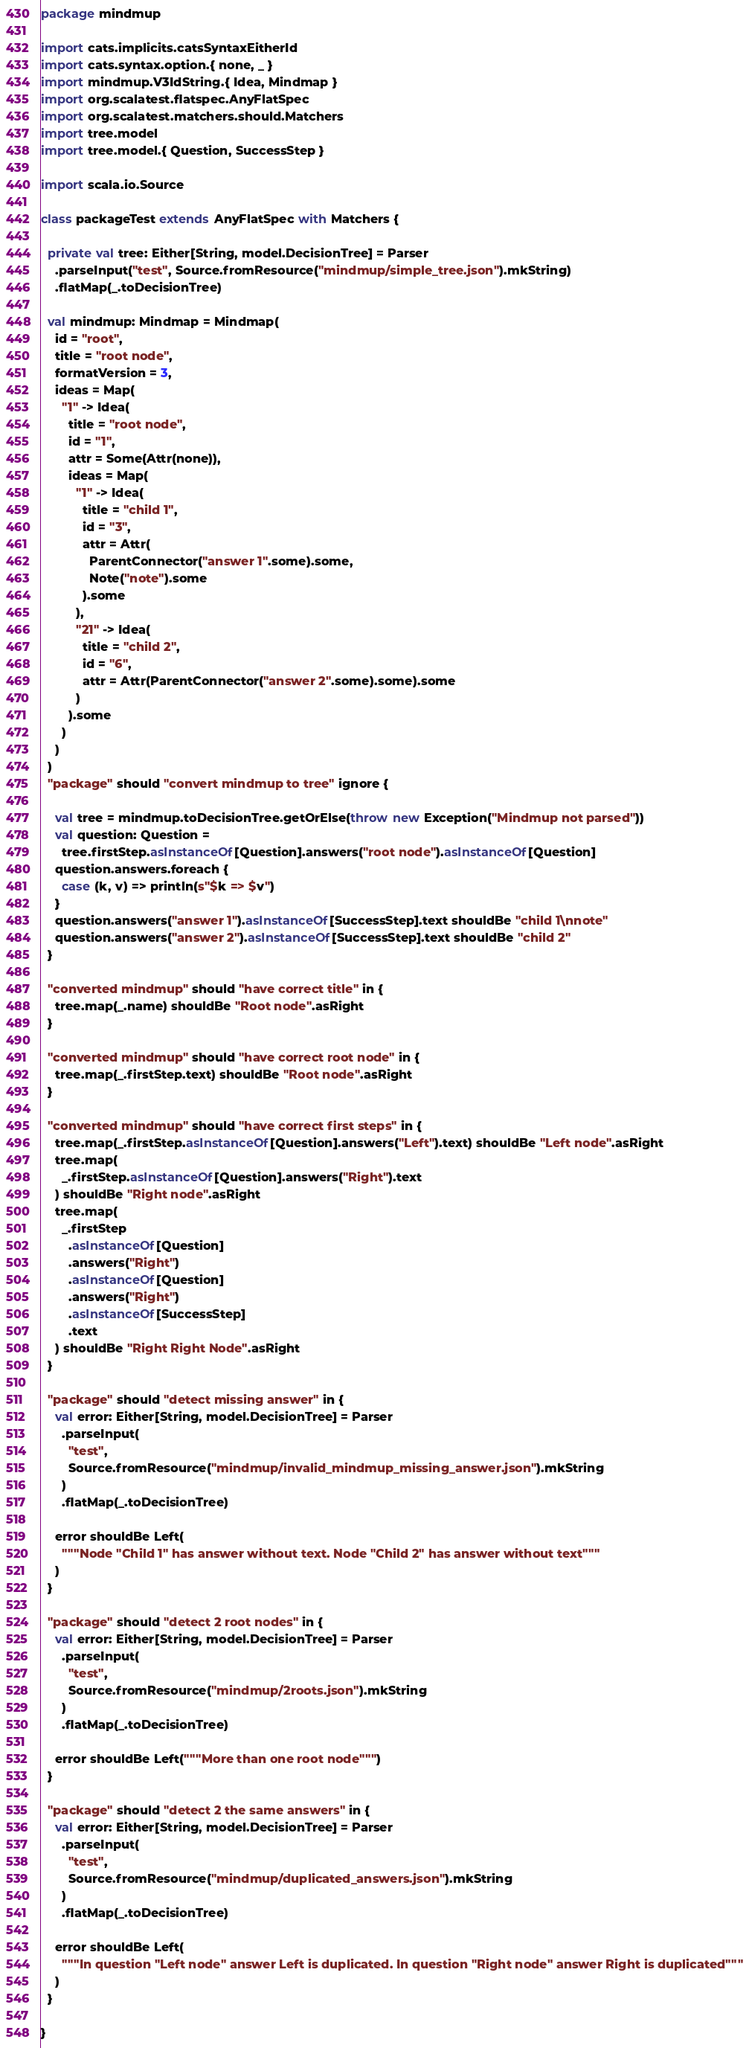Convert code to text. <code><loc_0><loc_0><loc_500><loc_500><_Scala_>package mindmup

import cats.implicits.catsSyntaxEitherId
import cats.syntax.option.{ none, _ }
import mindmup.V3IdString.{ Idea, Mindmap }
import org.scalatest.flatspec.AnyFlatSpec
import org.scalatest.matchers.should.Matchers
import tree.model
import tree.model.{ Question, SuccessStep }

import scala.io.Source

class packageTest extends AnyFlatSpec with Matchers {

  private val tree: Either[String, model.DecisionTree] = Parser
    .parseInput("test", Source.fromResource("mindmup/simple_tree.json").mkString)
    .flatMap(_.toDecisionTree)

  val mindmup: Mindmap = Mindmap(
    id = "root",
    title = "root node",
    formatVersion = 3,
    ideas = Map(
      "1" -> Idea(
        title = "root node",
        id = "1",
        attr = Some(Attr(none)),
        ideas = Map(
          "1" -> Idea(
            title = "child 1",
            id = "3",
            attr = Attr(
              ParentConnector("answer 1".some).some,
              Note("note").some
            ).some
          ),
          "21" -> Idea(
            title = "child 2",
            id = "6",
            attr = Attr(ParentConnector("answer 2".some).some).some
          )
        ).some
      )
    )
  )
  "package" should "convert mindmup to tree" ignore {

    val tree = mindmup.toDecisionTree.getOrElse(throw new Exception("Mindmup not parsed"))
    val question: Question =
      tree.firstStep.asInstanceOf[Question].answers("root node").asInstanceOf[Question]
    question.answers.foreach {
      case (k, v) => println(s"$k => $v")
    }
    question.answers("answer 1").asInstanceOf[SuccessStep].text shouldBe "child 1\nnote"
    question.answers("answer 2").asInstanceOf[SuccessStep].text shouldBe "child 2"
  }

  "converted mindmup" should "have correct title" in {
    tree.map(_.name) shouldBe "Root node".asRight
  }

  "converted mindmup" should "have correct root node" in {
    tree.map(_.firstStep.text) shouldBe "Root node".asRight
  }

  "converted mindmup" should "have correct first steps" in {
    tree.map(_.firstStep.asInstanceOf[Question].answers("Left").text) shouldBe "Left node".asRight
    tree.map(
      _.firstStep.asInstanceOf[Question].answers("Right").text
    ) shouldBe "Right node".asRight
    tree.map(
      _.firstStep
        .asInstanceOf[Question]
        .answers("Right")
        .asInstanceOf[Question]
        .answers("Right")
        .asInstanceOf[SuccessStep]
        .text
    ) shouldBe "Right Right Node".asRight
  }

  "package" should "detect missing answer" in {
    val error: Either[String, model.DecisionTree] = Parser
      .parseInput(
        "test",
        Source.fromResource("mindmup/invalid_mindmup_missing_answer.json").mkString
      )
      .flatMap(_.toDecisionTree)

    error shouldBe Left(
      """Node "Child 1" has answer without text. Node "Child 2" has answer without text"""
    )
  }

  "package" should "detect 2 root nodes" in {
    val error: Either[String, model.DecisionTree] = Parser
      .parseInput(
        "test",
        Source.fromResource("mindmup/2roots.json").mkString
      )
      .flatMap(_.toDecisionTree)

    error shouldBe Left("""More than one root node""")
  }

  "package" should "detect 2 the same answers" in {
    val error: Either[String, model.DecisionTree] = Parser
      .parseInput(
        "test",
        Source.fromResource("mindmup/duplicated_answers.json").mkString
      )
      .flatMap(_.toDecisionTree)

    error shouldBe Left(
      """In question "Left node" answer Left is duplicated. In question "Right node" answer Right is duplicated"""
    )
  }

}
</code> 